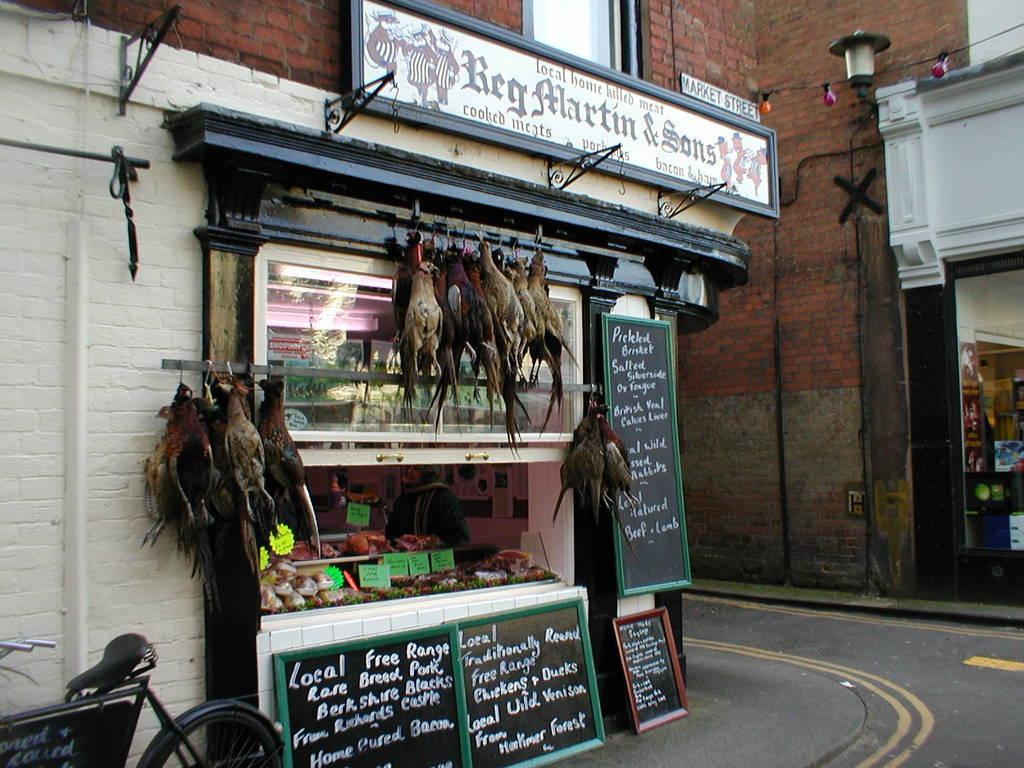In one or two sentences, can you explain what this image depicts? In this image, there is an outside view. There is a shop in the middle of the image contains some hens. There are boards at the bottom of the image. There is a cycle in the bottom left of the image. 